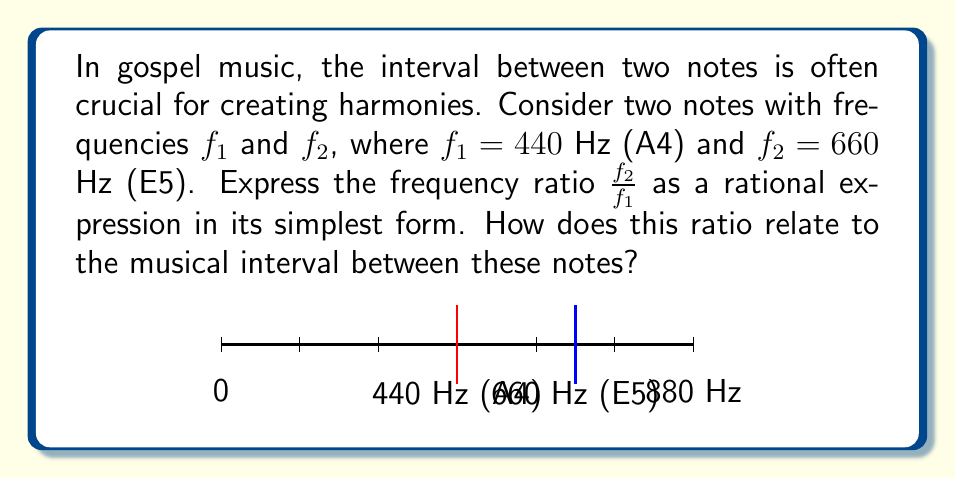Can you solve this math problem? 1) To calculate the frequency ratio, we divide $f_2$ by $f_1$:

   $$\frac{f_2}{f_1} = \frac{660 \text{ Hz}}{440 \text{ Hz}}$$

2) Simplify this fraction by dividing both numerator and denominator by their greatest common divisor (GCD):
   
   GCD(660, 440) = 220

   $$\frac{660 \div 220}{440 \div 220} = \frac{3}{2}$$

3) Therefore, the frequency ratio is $\frac{3}{2}$.

4) In music theory, this ratio $\frac{3}{2}$ corresponds to a perfect fifth interval. The perfect fifth is a common and important interval in gospel music, often used in harmonies and chord progressions.

5) To verify, we can express this ratio as a decimal:

   $$\frac{3}{2} = 1.5$$

   This means the higher note ($f_2$) has a frequency 1.5 times that of the lower note ($f_1$).
Answer: $\frac{3}{2}$, representing a perfect fifth 